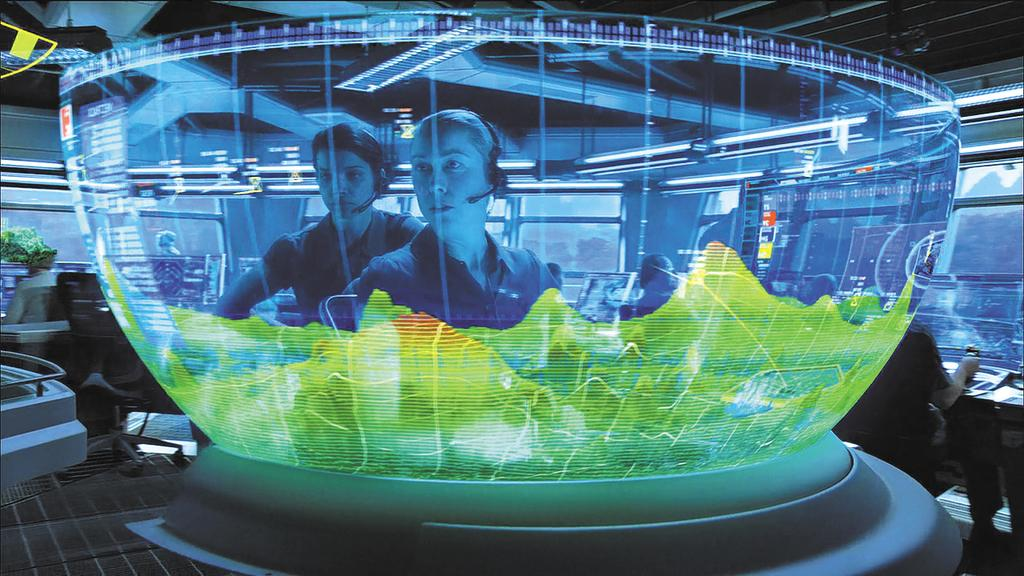How many people are in the group visible in the image? There is a group of people in the image, but the exact number cannot be determined from the provided facts. What type of furniture is present in the image? There are chairs and tables on the floor in the image. What type of plant is visible in the image? There is a houseplant in the image. Where is the image likely taken? The image appears to be taken in a hall. What can be seen at the top of the image? There is a rooftop visible at the top of the image. What type of hill can be seen in the image? There is no hill present in the image; it appears to be taken in a hall with a rooftop visible at the top. What act are the people in the image performing? The provided facts do not mention any specific act or activity being performed by the people in the image. 